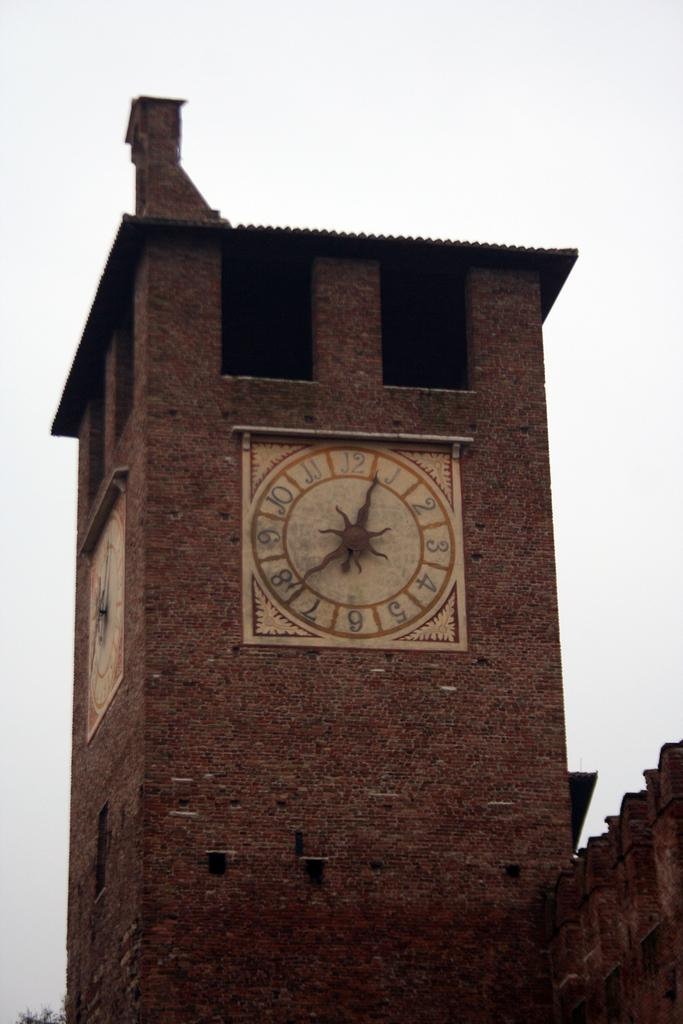Provide a one-sentence caption for the provided image. A clock on the side of brick wall points to the numbers 1 and 8. 